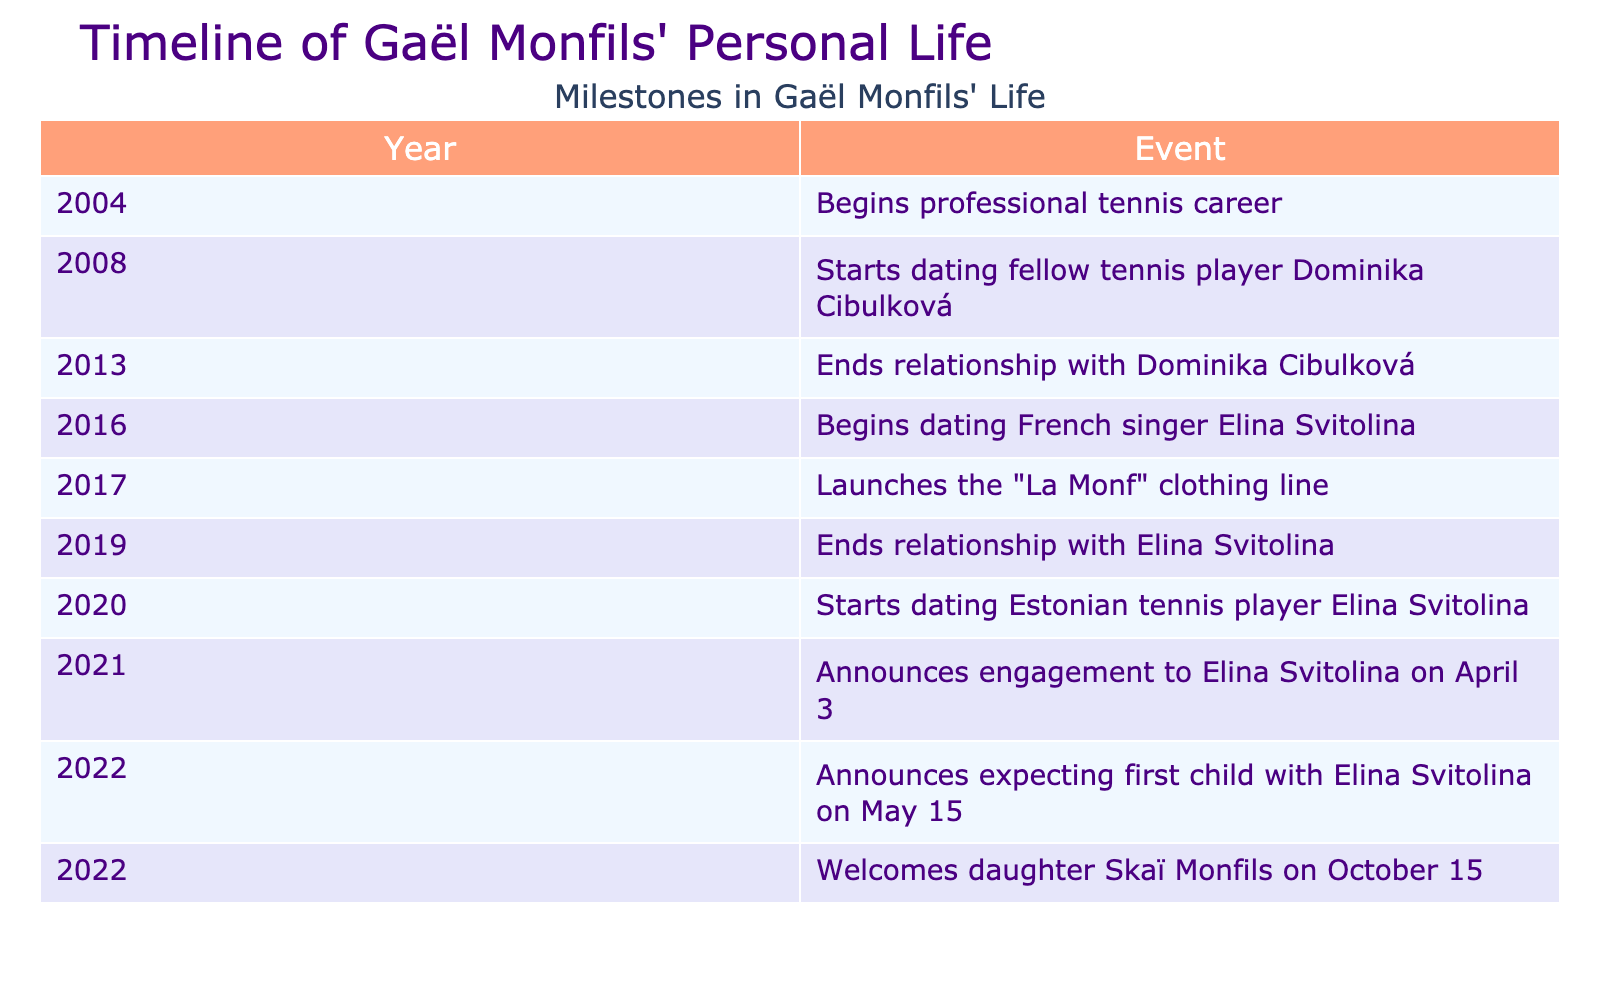What year did Gaël Monfils begin his professional tennis career? The table lists 2004 as the year when Gaël Monfils began his professional tennis career.
Answer: 2004 How many relationships did Gaël Monfils have according to the table? The table indicates two relationships: one with Dominika Cibulková and another with Elina Svitolina. Therefore, the count is two.
Answer: 2 In which year did Gaël Monfils launch his clothing line? The table states that he launched the "La Monf" clothing line in 2017.
Answer: 2017 Did Gaël Monfils announce expecting a child with Elina Svitolina? Yes, the table shows that he announced expecting his first child with Elina Svitolina on May 15, 2022.
Answer: Yes What is the time gap between the end of Gaël Monfils' relationship with Dominika Cibulková and the beginning of his dating relationship with Elina Svitolina? Gaël Monfils ended his relationship with Dominika Cibulková in 2013 and began dating Elina Svitolina in 2016. The time gap is from 2013 to 2016, which is 3 years.
Answer: 3 years What milestone occurred after the launch of "La Monf"? After the launch of "La Monf" clothing line in 2017, the next milestone is the end of his relationship with Elina Svitolina in 2019.
Answer: The end of relationship with Elina Svitolina in 2019 Which event was the first milestone in Gaël Monfils' personal life? According to the table, the first milestone is the beginning of his professional tennis career in 2004.
Answer: Begins professional tennis career in 2004 How many milestones happen in the year 2022? The table shows that there are two milestones for the year 2022: announcing expecting his first child on May 15 and welcoming his daughter on October 15.
Answer: 2 Did Gaël Monfils and Elina Svitolina start dating in the same year they ended their previous relationships? Gaël Monfils ended his relationship with Dominika Cibulková in 2013 and started dating Elina Svitolina in 2016. Since there is a gap of 3 years, the answer is no.
Answer: No 